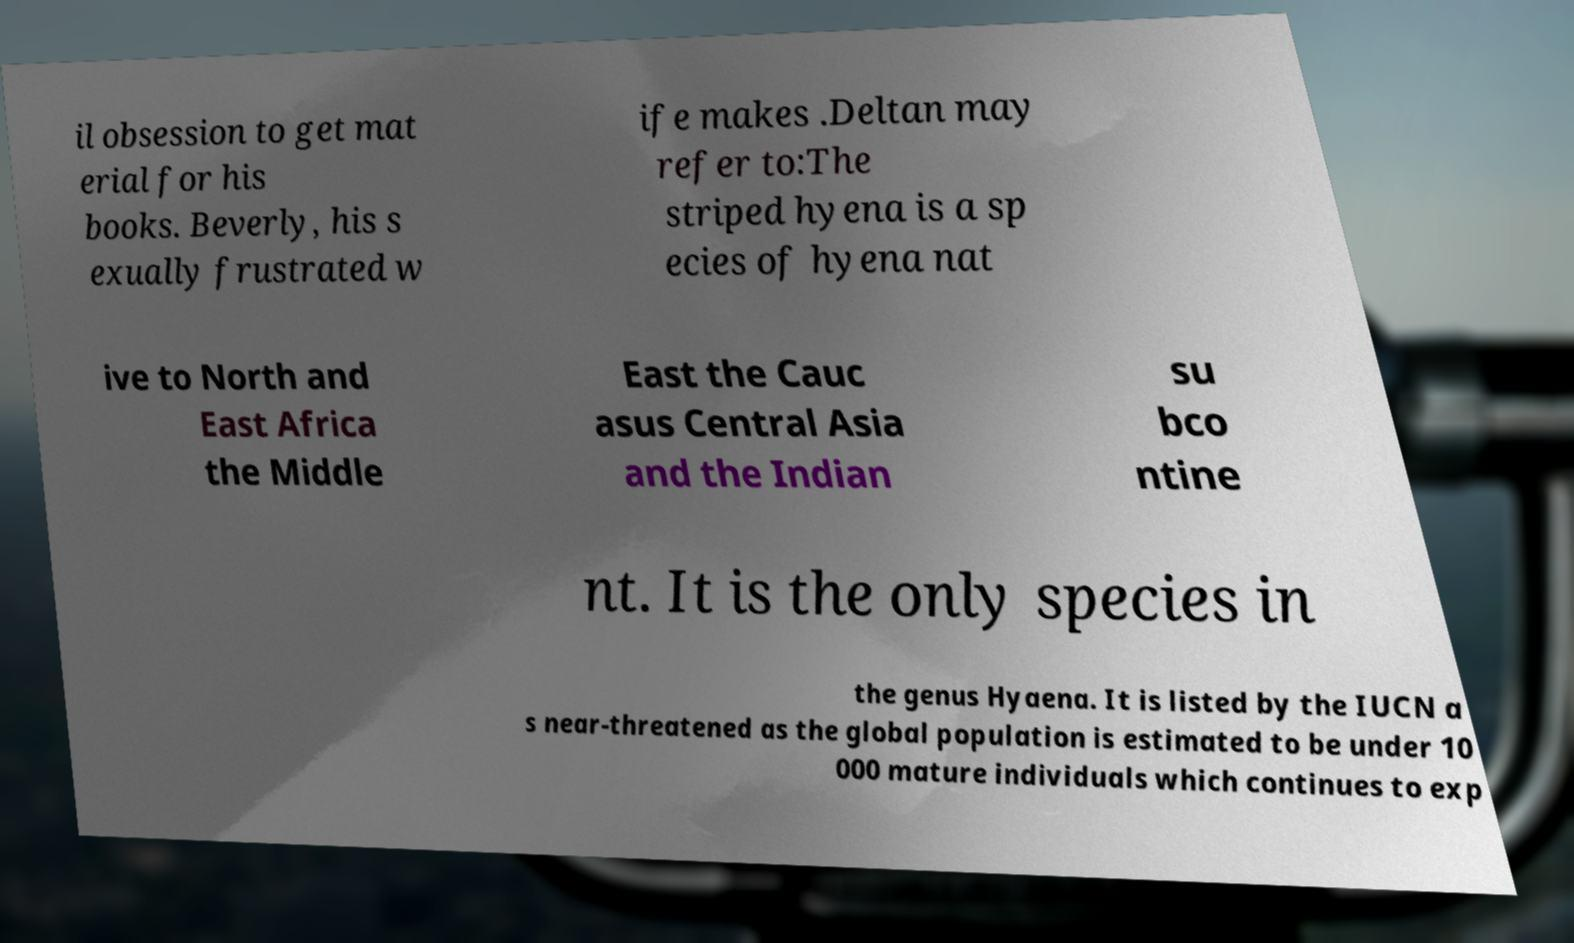Could you extract and type out the text from this image? il obsession to get mat erial for his books. Beverly, his s exually frustrated w ife makes .Deltan may refer to:The striped hyena is a sp ecies of hyena nat ive to North and East Africa the Middle East the Cauc asus Central Asia and the Indian su bco ntine nt. It is the only species in the genus Hyaena. It is listed by the IUCN a s near-threatened as the global population is estimated to be under 10 000 mature individuals which continues to exp 